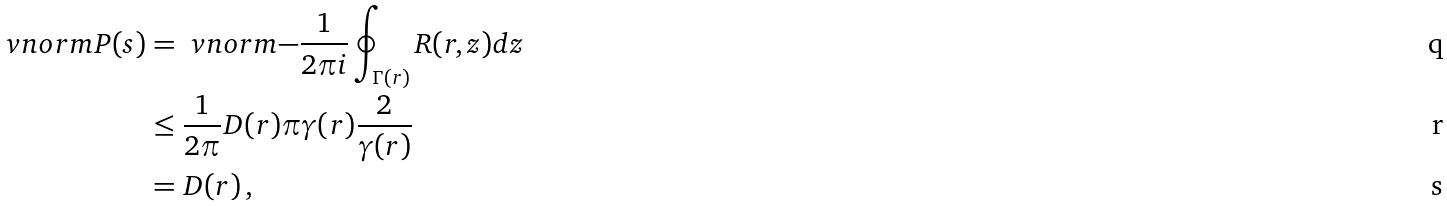<formula> <loc_0><loc_0><loc_500><loc_500>\ v n o r m { P ( s ) } & = \ v n o r m { - \frac { 1 } { 2 \pi i } \oint _ { \Gamma ( r ) } R ( r , z ) d z } \\ & \leq \frac { 1 } { 2 \pi } D ( r ) \pi \gamma ( r ) \frac { 2 } { \gamma ( r ) } \\ & = D ( r ) \, ,</formula> 